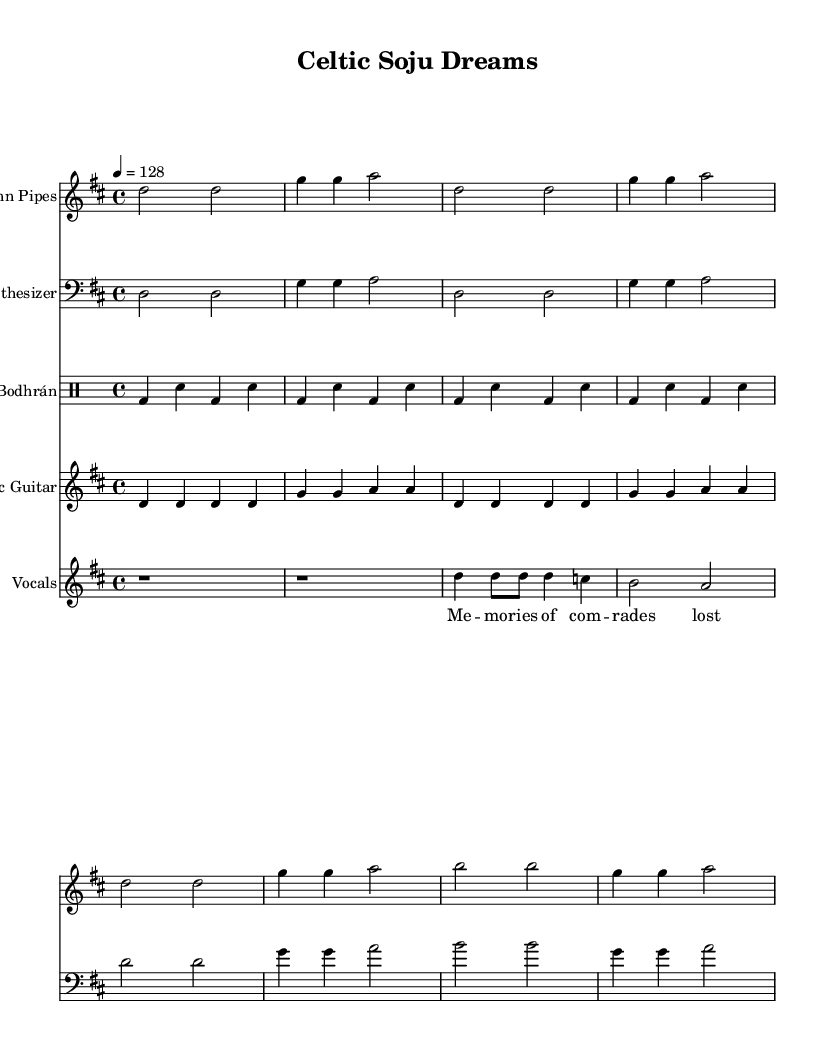What is the key signature of this music? The key signature of the piece is D major, which has two sharps (F# and C#). This can be determined from the key indicated at the beginning of the score, marked as "d" in the global context.
Answer: D major What is the time signature of the music? The time signature is 4/4, meaning there are four beats in each measure and a quarter note gets one beat. This is indicated in the global section of the score.
Answer: 4/4 What is the tempo marking of the piece? The tempo marking indicates a speed of 128 beats per minute (BPM). This can be found specified in the global context where it states "4 = 128".
Answer: 128 How many measures are present in the section for uilleann pipes? The provided music for the uilleann pipes consists of 8 measures in total, counting each measure sequentially from the beginning to the end of the indicated lines for this instrument.
Answer: 8 measures What are the two instruments primarily used in this collaboration besides vocals? The two instruments noted in this collaboration, apart from vocals, are the uilleann pipes and the electric guitar. This can be verified by observing the distinct staves dedicated to each instrument in the score.
Answer: Uilleann pipes and electric guitar Which rhythm pattern is used for the bodhrán segment? The rhythm pattern used for the bodhrán is a simplified pattern of bass and snare hits played in succession, which can be confirmed by examining the drummode section within the score for the bodhrán instrument.
Answer: Bass and snare pattern What emotions do the lyrics convey in this music? The lyrics depicted in the music refer to "memories of comrades lost," suggesting themes of remembrance and nostalgia. This is found in the vocal section, specifically within the written lyrics corresponding to the voice part.
Answer: Memories of comrades lost 